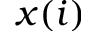<formula> <loc_0><loc_0><loc_500><loc_500>x ( i )</formula> 